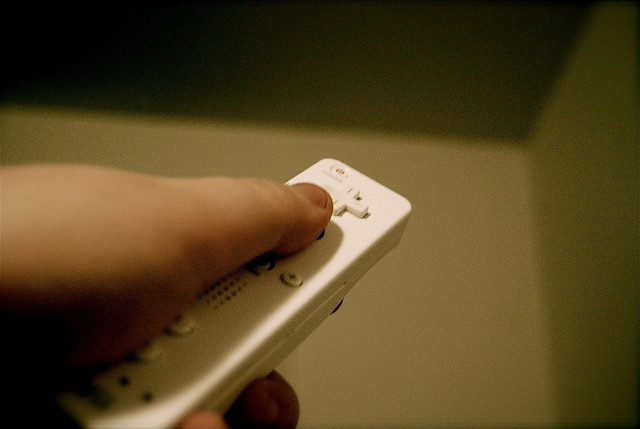Describe the objects in this image and their specific colors. I can see people in black, tan, maroon, and brown tones and remote in black, olive, lightgray, and maroon tones in this image. 